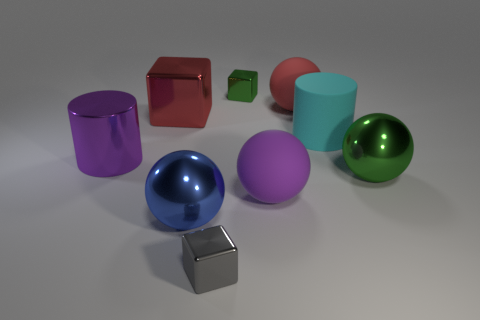What number of brown things are blocks or large metallic spheres?
Keep it short and to the point. 0. What is the color of the metallic cylinder?
Your answer should be compact. Purple. Does the cyan cylinder have the same size as the gray metal block?
Make the answer very short. No. Does the large purple cylinder have the same material as the cylinder that is right of the small gray shiny object?
Provide a succinct answer. No. Does the big sphere that is behind the big cyan matte cylinder have the same color as the big metal block?
Keep it short and to the point. Yes. What number of shiny cubes are behind the blue object and in front of the small green shiny cube?
Your answer should be compact. 1. What number of other objects are there of the same material as the red cube?
Your answer should be compact. 5. Is the material of the tiny thing that is in front of the large purple sphere the same as the small green block?
Give a very brief answer. Yes. There is a thing that is on the right side of the big cylinder behind the cylinder that is on the left side of the large red cube; what is its size?
Provide a succinct answer. Large. What number of other objects are the same color as the big shiny cube?
Your response must be concise. 1. 